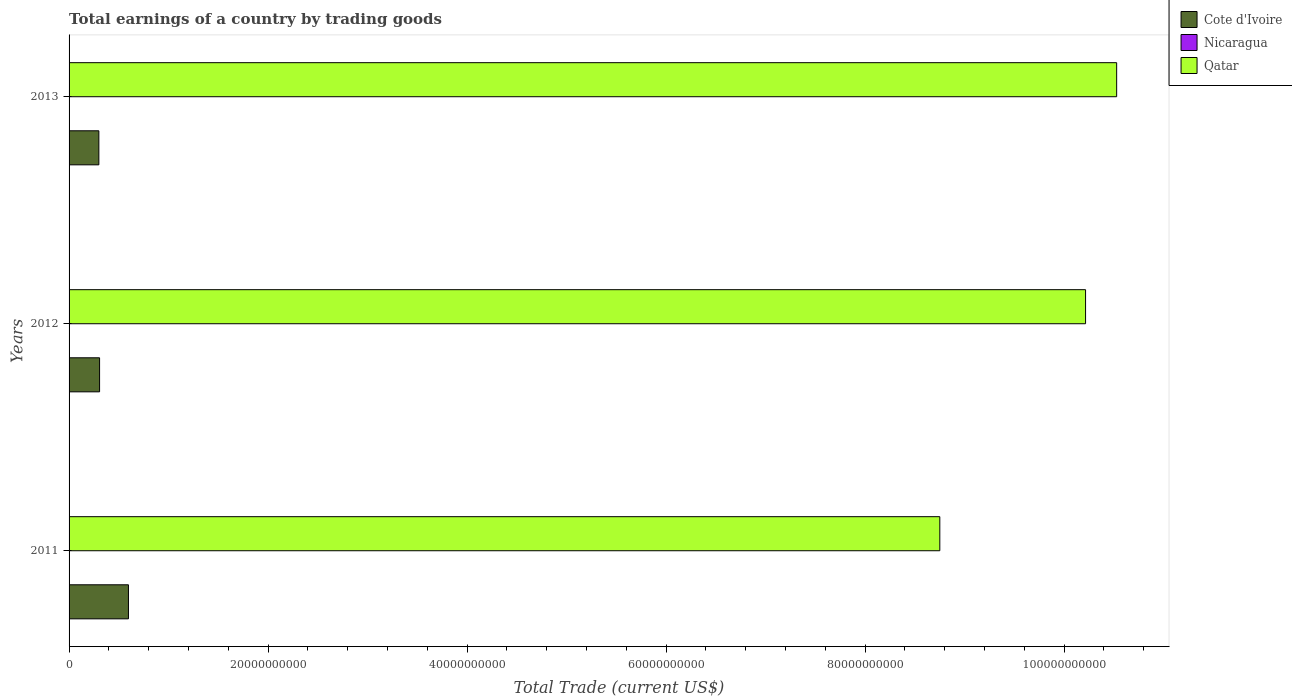How many different coloured bars are there?
Give a very brief answer. 2. How many bars are there on the 2nd tick from the top?
Offer a terse response. 2. How many bars are there on the 2nd tick from the bottom?
Ensure brevity in your answer.  2. What is the total earnings in Cote d'Ivoire in 2012?
Offer a very short reply. 3.07e+09. Across all years, what is the maximum total earnings in Cote d'Ivoire?
Your answer should be compact. 5.97e+09. In which year was the total earnings in Cote d'Ivoire maximum?
Offer a terse response. 2011. What is the difference between the total earnings in Qatar in 2011 and that in 2012?
Make the answer very short. -1.46e+1. What is the difference between the total earnings in Cote d'Ivoire in 2011 and the total earnings in Qatar in 2013?
Your answer should be very brief. -9.93e+1. What is the average total earnings in Cote d'Ivoire per year?
Make the answer very short. 4.01e+09. In the year 2013, what is the difference between the total earnings in Qatar and total earnings in Cote d'Ivoire?
Provide a succinct answer. 1.02e+11. What is the ratio of the total earnings in Qatar in 2012 to that in 2013?
Provide a succinct answer. 0.97. What is the difference between the highest and the second highest total earnings in Cote d'Ivoire?
Ensure brevity in your answer.  2.90e+09. What is the difference between the highest and the lowest total earnings in Qatar?
Offer a very short reply. 1.78e+1. In how many years, is the total earnings in Nicaragua greater than the average total earnings in Nicaragua taken over all years?
Offer a very short reply. 0. Is the sum of the total earnings in Qatar in 2011 and 2012 greater than the maximum total earnings in Nicaragua across all years?
Your answer should be compact. Yes. Does the graph contain grids?
Offer a very short reply. No. Where does the legend appear in the graph?
Your answer should be compact. Top right. How many legend labels are there?
Make the answer very short. 3. What is the title of the graph?
Provide a succinct answer. Total earnings of a country by trading goods. What is the label or title of the X-axis?
Give a very brief answer. Total Trade (current US$). What is the Total Trade (current US$) in Cote d'Ivoire in 2011?
Offer a terse response. 5.97e+09. What is the Total Trade (current US$) in Nicaragua in 2011?
Ensure brevity in your answer.  0. What is the Total Trade (current US$) of Qatar in 2011?
Make the answer very short. 8.75e+1. What is the Total Trade (current US$) in Cote d'Ivoire in 2012?
Offer a terse response. 3.07e+09. What is the Total Trade (current US$) of Nicaragua in 2012?
Ensure brevity in your answer.  0. What is the Total Trade (current US$) of Qatar in 2012?
Offer a very short reply. 1.02e+11. What is the Total Trade (current US$) of Cote d'Ivoire in 2013?
Keep it short and to the point. 2.99e+09. What is the Total Trade (current US$) in Qatar in 2013?
Keep it short and to the point. 1.05e+11. Across all years, what is the maximum Total Trade (current US$) of Cote d'Ivoire?
Keep it short and to the point. 5.97e+09. Across all years, what is the maximum Total Trade (current US$) of Qatar?
Provide a short and direct response. 1.05e+11. Across all years, what is the minimum Total Trade (current US$) of Cote d'Ivoire?
Your answer should be very brief. 2.99e+09. Across all years, what is the minimum Total Trade (current US$) of Qatar?
Offer a very short reply. 8.75e+1. What is the total Total Trade (current US$) of Cote d'Ivoire in the graph?
Make the answer very short. 1.20e+1. What is the total Total Trade (current US$) in Nicaragua in the graph?
Your response must be concise. 0. What is the total Total Trade (current US$) of Qatar in the graph?
Your answer should be very brief. 2.95e+11. What is the difference between the Total Trade (current US$) of Cote d'Ivoire in 2011 and that in 2012?
Give a very brief answer. 2.90e+09. What is the difference between the Total Trade (current US$) in Qatar in 2011 and that in 2012?
Offer a terse response. -1.46e+1. What is the difference between the Total Trade (current US$) in Cote d'Ivoire in 2011 and that in 2013?
Offer a very short reply. 2.97e+09. What is the difference between the Total Trade (current US$) of Qatar in 2011 and that in 2013?
Your response must be concise. -1.78e+1. What is the difference between the Total Trade (current US$) of Cote d'Ivoire in 2012 and that in 2013?
Provide a succinct answer. 7.26e+07. What is the difference between the Total Trade (current US$) of Qatar in 2012 and that in 2013?
Give a very brief answer. -3.13e+09. What is the difference between the Total Trade (current US$) of Cote d'Ivoire in 2011 and the Total Trade (current US$) of Qatar in 2012?
Keep it short and to the point. -9.62e+1. What is the difference between the Total Trade (current US$) in Cote d'Ivoire in 2011 and the Total Trade (current US$) in Qatar in 2013?
Provide a short and direct response. -9.93e+1. What is the difference between the Total Trade (current US$) in Cote d'Ivoire in 2012 and the Total Trade (current US$) in Qatar in 2013?
Give a very brief answer. -1.02e+11. What is the average Total Trade (current US$) in Cote d'Ivoire per year?
Provide a short and direct response. 4.01e+09. What is the average Total Trade (current US$) in Nicaragua per year?
Your answer should be compact. 0. What is the average Total Trade (current US$) in Qatar per year?
Make the answer very short. 9.83e+1. In the year 2011, what is the difference between the Total Trade (current US$) in Cote d'Ivoire and Total Trade (current US$) in Qatar?
Your answer should be compact. -8.15e+1. In the year 2012, what is the difference between the Total Trade (current US$) of Cote d'Ivoire and Total Trade (current US$) of Qatar?
Ensure brevity in your answer.  -9.91e+1. In the year 2013, what is the difference between the Total Trade (current US$) in Cote d'Ivoire and Total Trade (current US$) in Qatar?
Make the answer very short. -1.02e+11. What is the ratio of the Total Trade (current US$) in Cote d'Ivoire in 2011 to that in 2012?
Make the answer very short. 1.95. What is the ratio of the Total Trade (current US$) of Qatar in 2011 to that in 2012?
Offer a terse response. 0.86. What is the ratio of the Total Trade (current US$) in Cote d'Ivoire in 2011 to that in 2013?
Keep it short and to the point. 1.99. What is the ratio of the Total Trade (current US$) of Qatar in 2011 to that in 2013?
Give a very brief answer. 0.83. What is the ratio of the Total Trade (current US$) in Cote d'Ivoire in 2012 to that in 2013?
Your response must be concise. 1.02. What is the ratio of the Total Trade (current US$) of Qatar in 2012 to that in 2013?
Keep it short and to the point. 0.97. What is the difference between the highest and the second highest Total Trade (current US$) in Cote d'Ivoire?
Ensure brevity in your answer.  2.90e+09. What is the difference between the highest and the second highest Total Trade (current US$) of Qatar?
Make the answer very short. 3.13e+09. What is the difference between the highest and the lowest Total Trade (current US$) of Cote d'Ivoire?
Offer a terse response. 2.97e+09. What is the difference between the highest and the lowest Total Trade (current US$) in Qatar?
Your answer should be compact. 1.78e+1. 